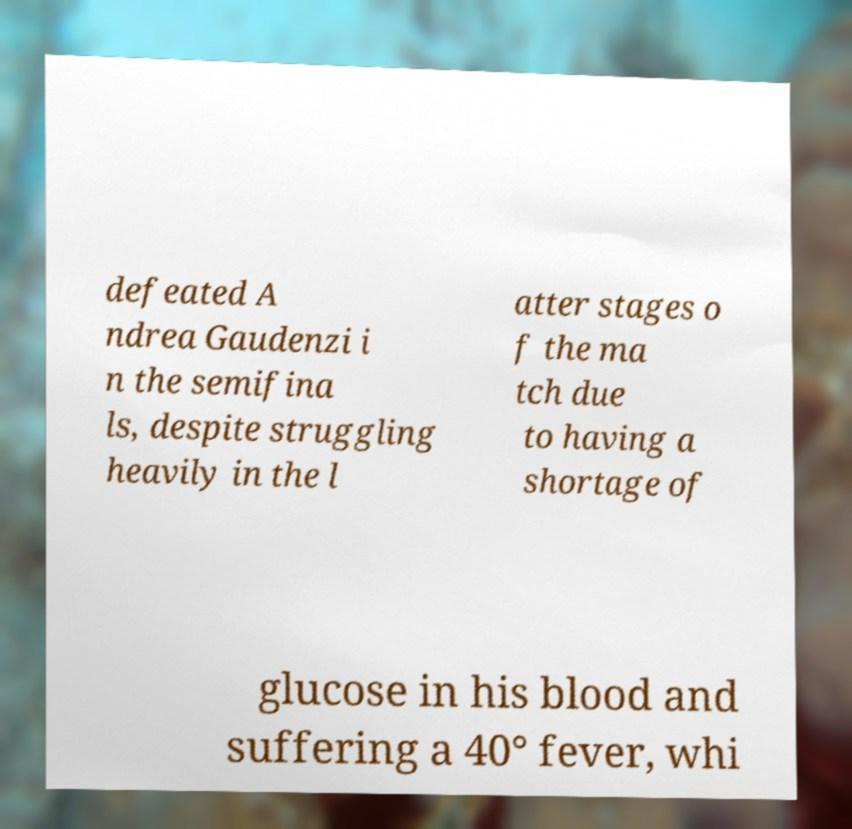Please read and relay the text visible in this image. What does it say? defeated A ndrea Gaudenzi i n the semifina ls, despite struggling heavily in the l atter stages o f the ma tch due to having a shortage of glucose in his blood and suffering a 40° fever, whi 